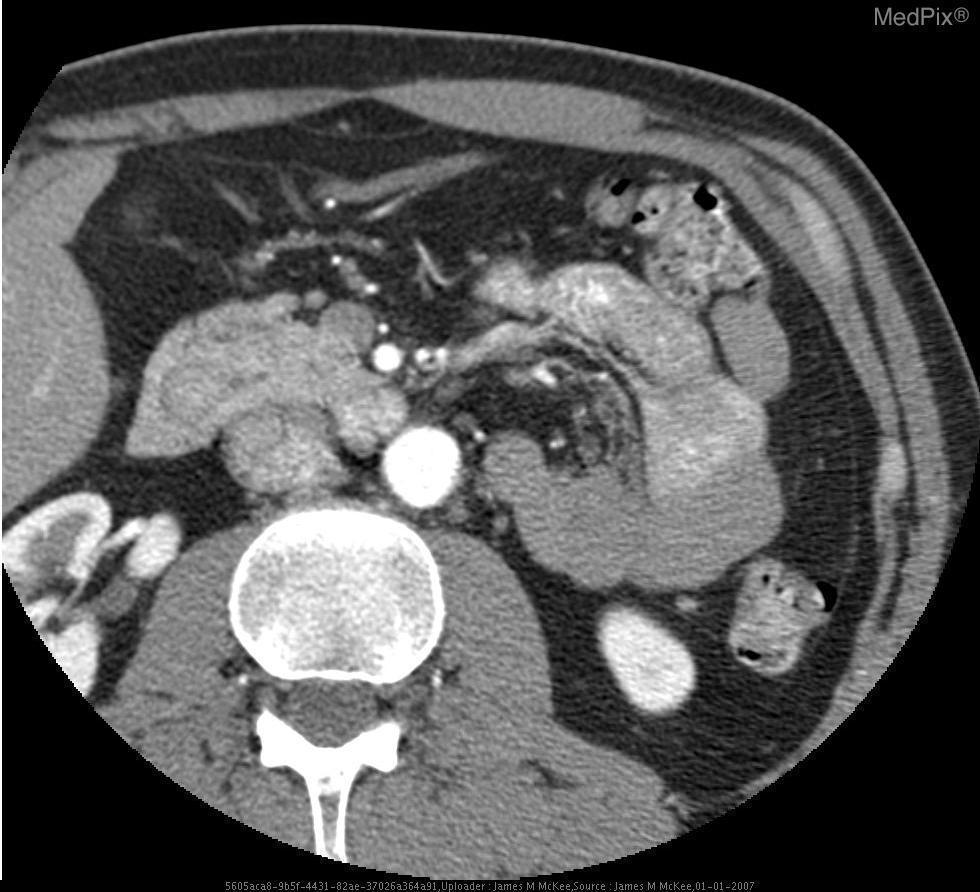Is the contrast in the bowels or the vasculature?
Give a very brief answer. In the vasculature. Are both kidneys visualized?
Short answer required. Yes. Can you see both kidneys in this image?
Write a very short answer. Yes. Is there evidence of calcification in the pancreas?
Concise answer only. No. Is the pancreas calcified?
Keep it brief. No. Is this in the lumbar vertebral level?
Quick response, please. Yes. Was oral or iv contrast used?
Concise answer only. Both. What organ system is primarily present in this image?
Be succinct. Gastrointestinal. How would you describe the duodenum?
Write a very short answer. Edematous. Is the duodenum edematous?
Quick response, please. Yes. 